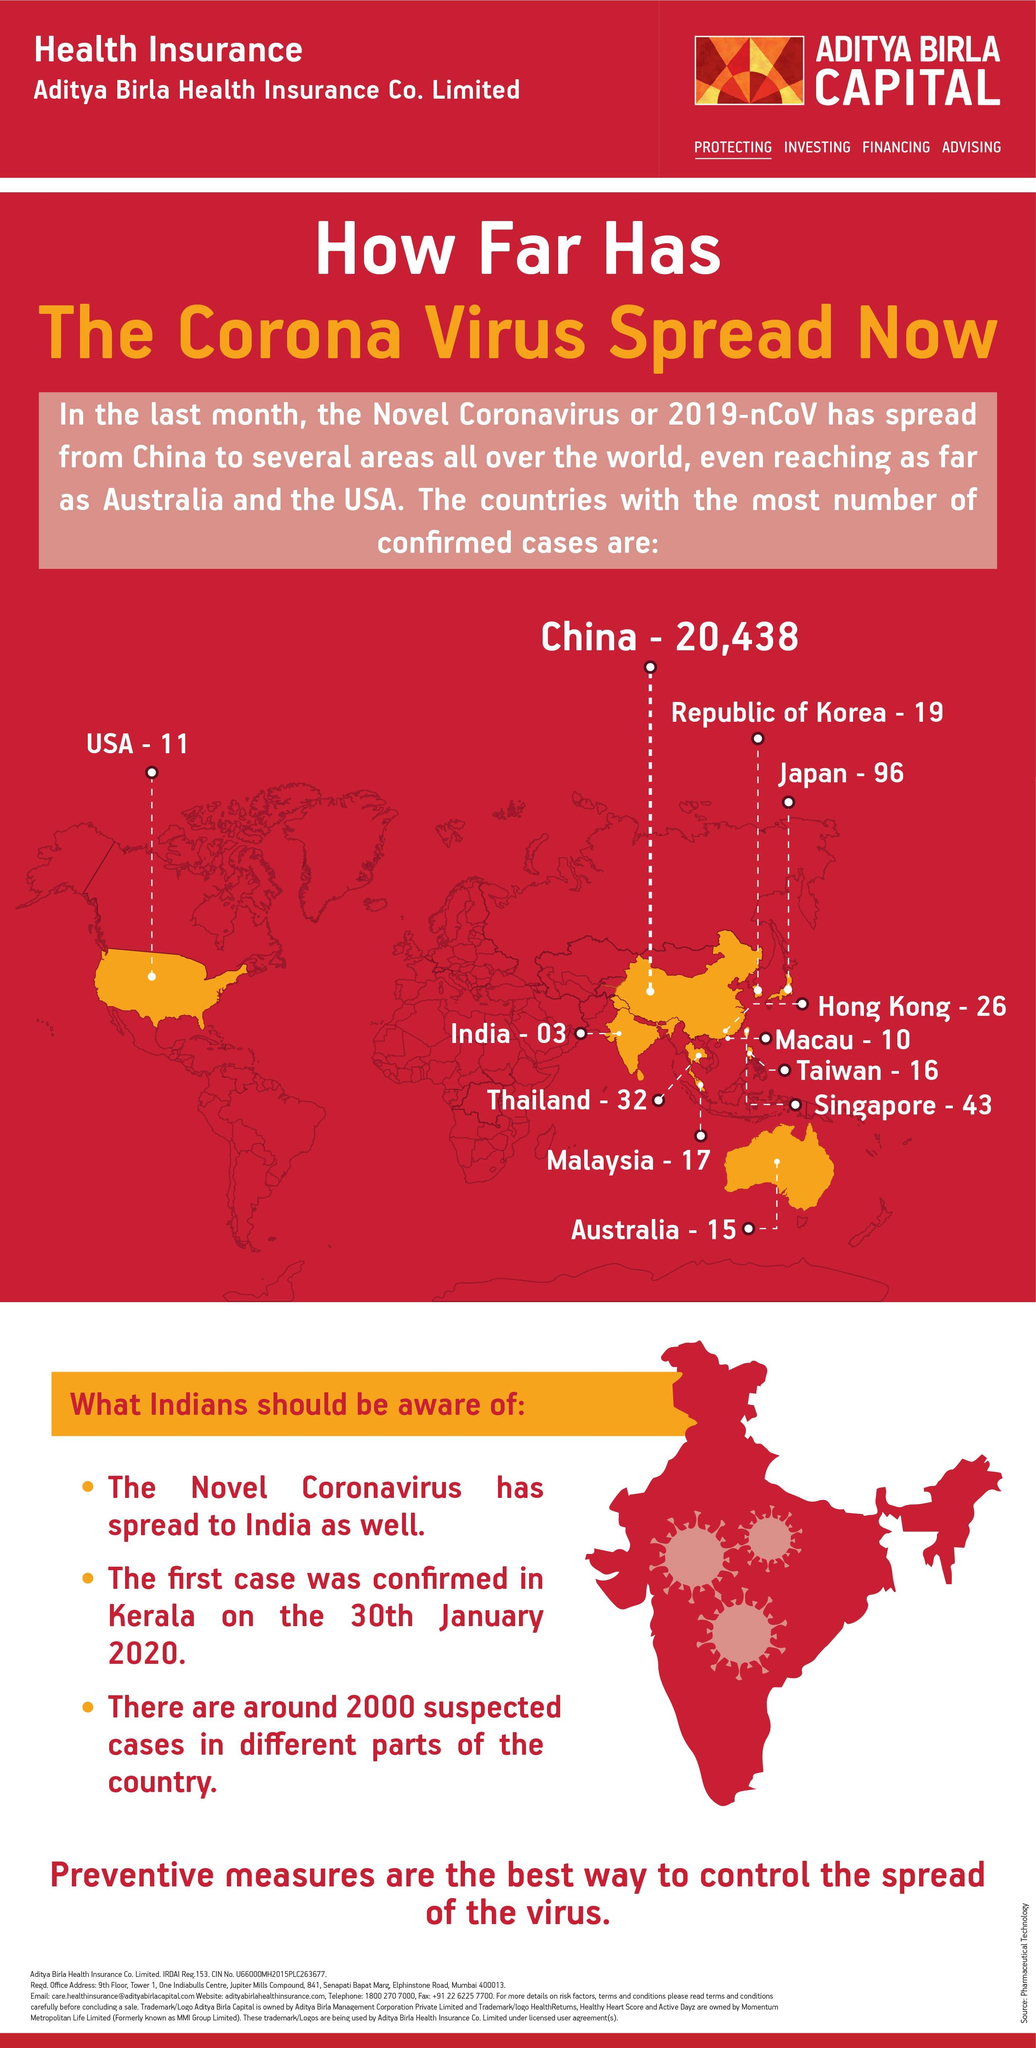Give some essential details in this illustration. Singapore has reported the third highest number of confirmed COVID-19 cases among the given countries. Japan has reported the second highest number of confirmed COVID-19 cases among the given countries. There were 15 confirmed cases of COVID-19 reported in Australia as of today. As of January 3, the number of confirmed positive cases of COVID-19 reported in India was zero. 